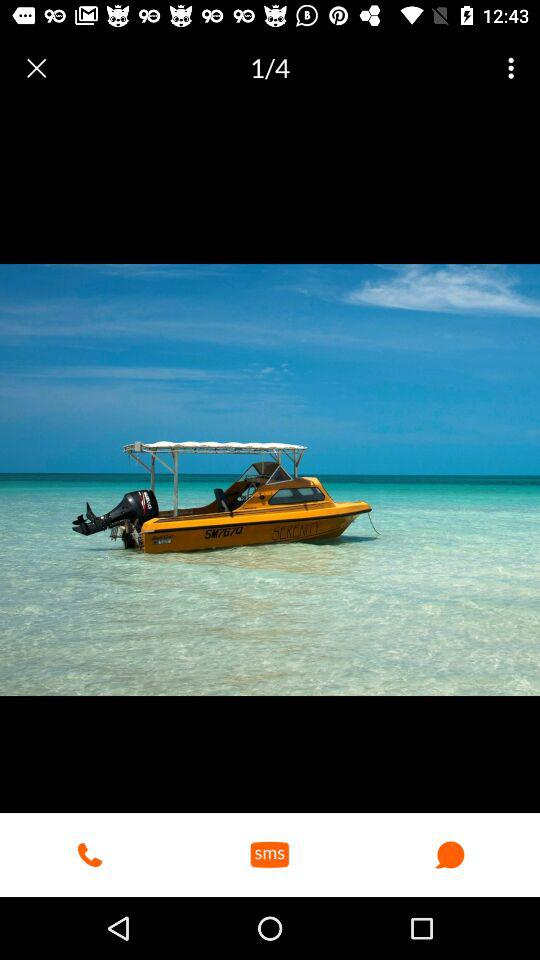What is the total number of images? The total number of images is 4. 